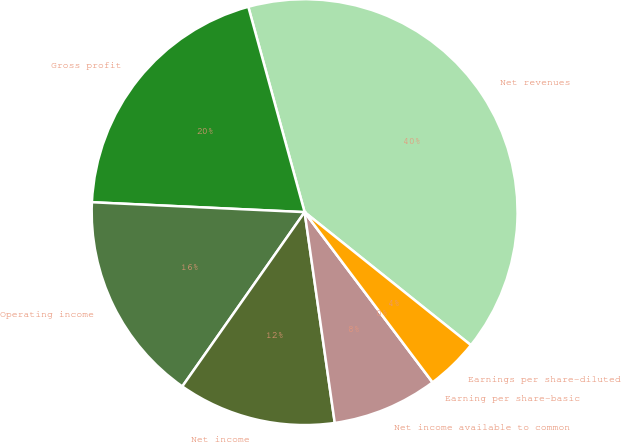Convert chart. <chart><loc_0><loc_0><loc_500><loc_500><pie_chart><fcel>Net revenues<fcel>Gross profit<fcel>Operating income<fcel>Net income<fcel>Net income available to common<fcel>Earning per share-basic<fcel>Earnings per share-diluted<nl><fcel>40.0%<fcel>20.0%<fcel>16.0%<fcel>12.0%<fcel>8.0%<fcel>0.0%<fcel>4.0%<nl></chart> 